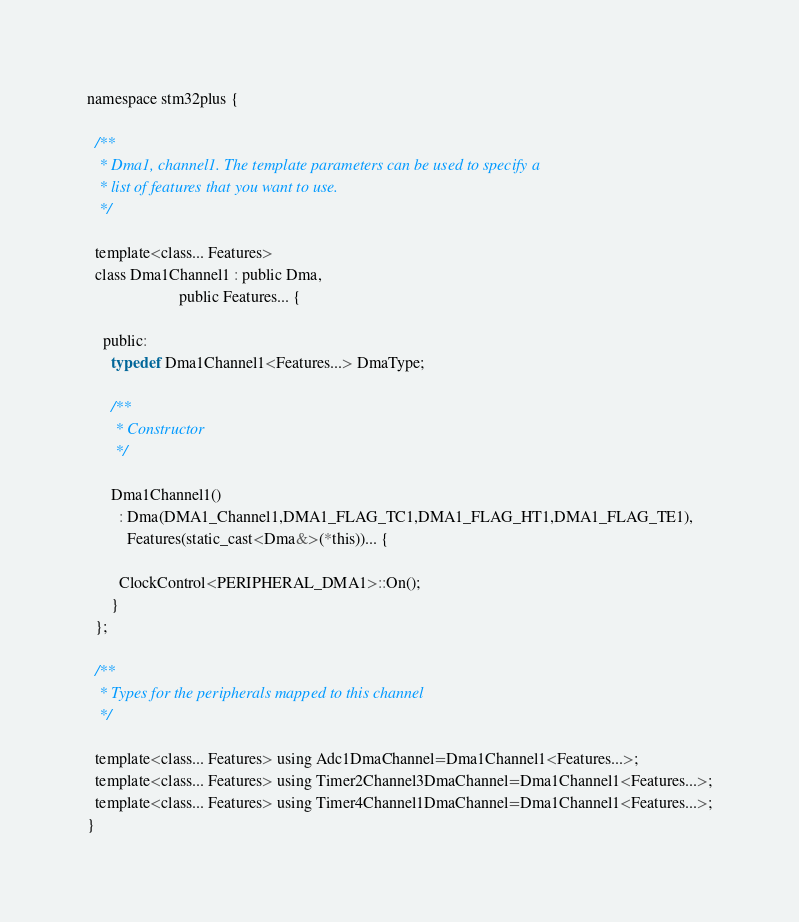<code> <loc_0><loc_0><loc_500><loc_500><_C_>
namespace stm32plus {

  /**
   * Dma1, channel1. The template parameters can be used to specify a
   * list of features that you want to use.
   */

  template<class... Features>
  class Dma1Channel1 : public Dma,
                       public Features... {

    public:
      typedef Dma1Channel1<Features...> DmaType;

      /**
       * Constructor
       */

      Dma1Channel1()
        : Dma(DMA1_Channel1,DMA1_FLAG_TC1,DMA1_FLAG_HT1,DMA1_FLAG_TE1),
          Features(static_cast<Dma&>(*this))... {

        ClockControl<PERIPHERAL_DMA1>::On();
      }
  };

  /**
   * Types for the peripherals mapped to this channel
   */

  template<class... Features> using Adc1DmaChannel=Dma1Channel1<Features...>;
  template<class... Features> using Timer2Channel3DmaChannel=Dma1Channel1<Features...>;
  template<class... Features> using Timer4Channel1DmaChannel=Dma1Channel1<Features...>;
}
</code> 